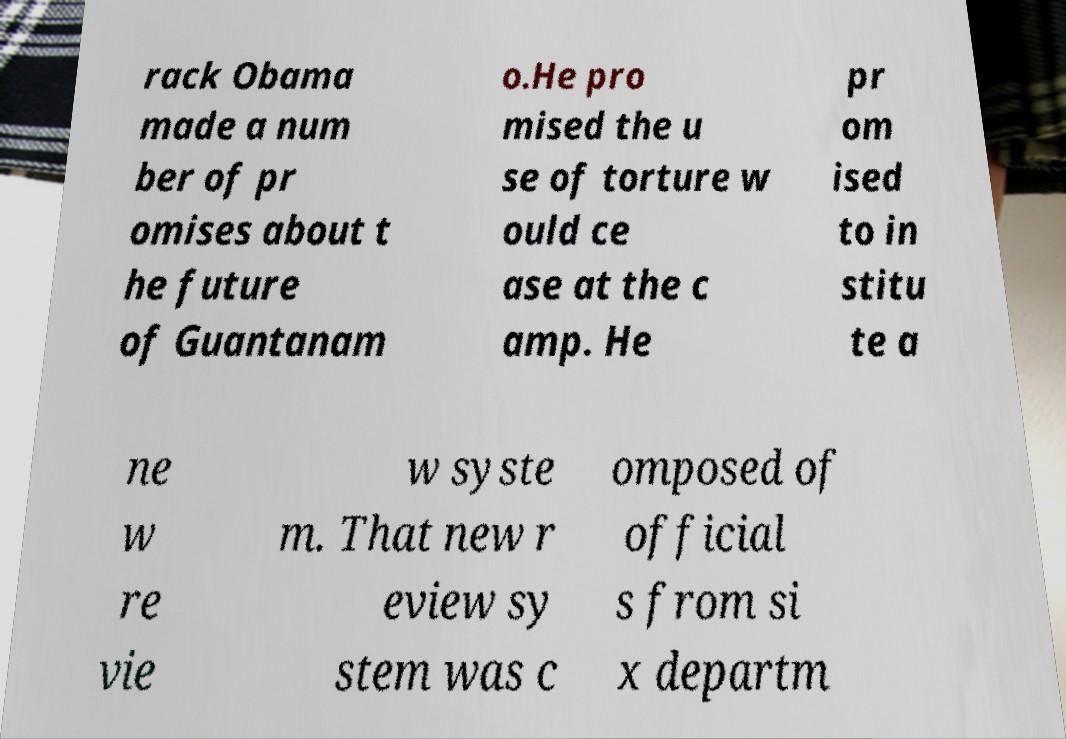Can you read and provide the text displayed in the image?This photo seems to have some interesting text. Can you extract and type it out for me? rack Obama made a num ber of pr omises about t he future of Guantanam o.He pro mised the u se of torture w ould ce ase at the c amp. He pr om ised to in stitu te a ne w re vie w syste m. That new r eview sy stem was c omposed of official s from si x departm 